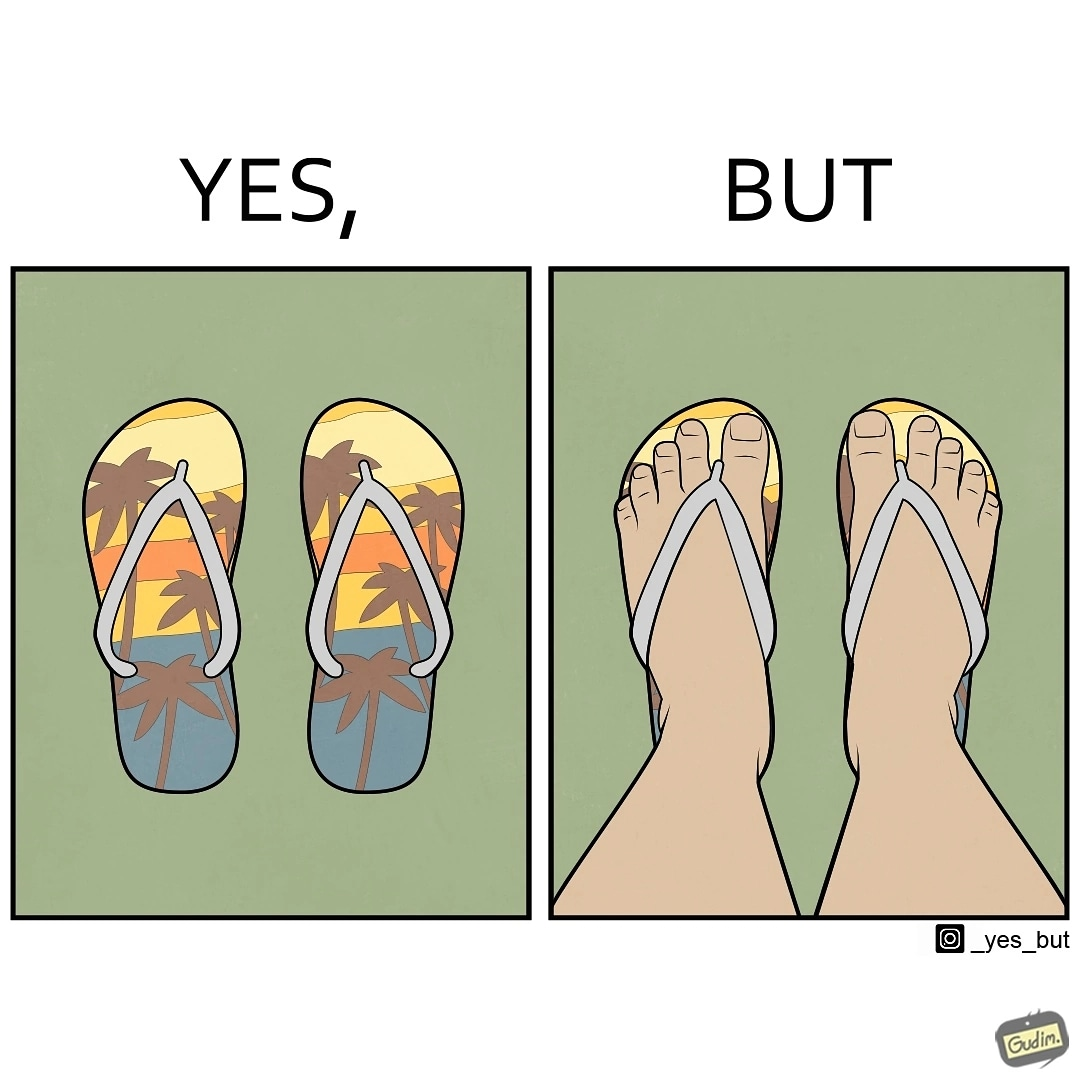Is there satirical content in this image? Yes, this image is satirical. 